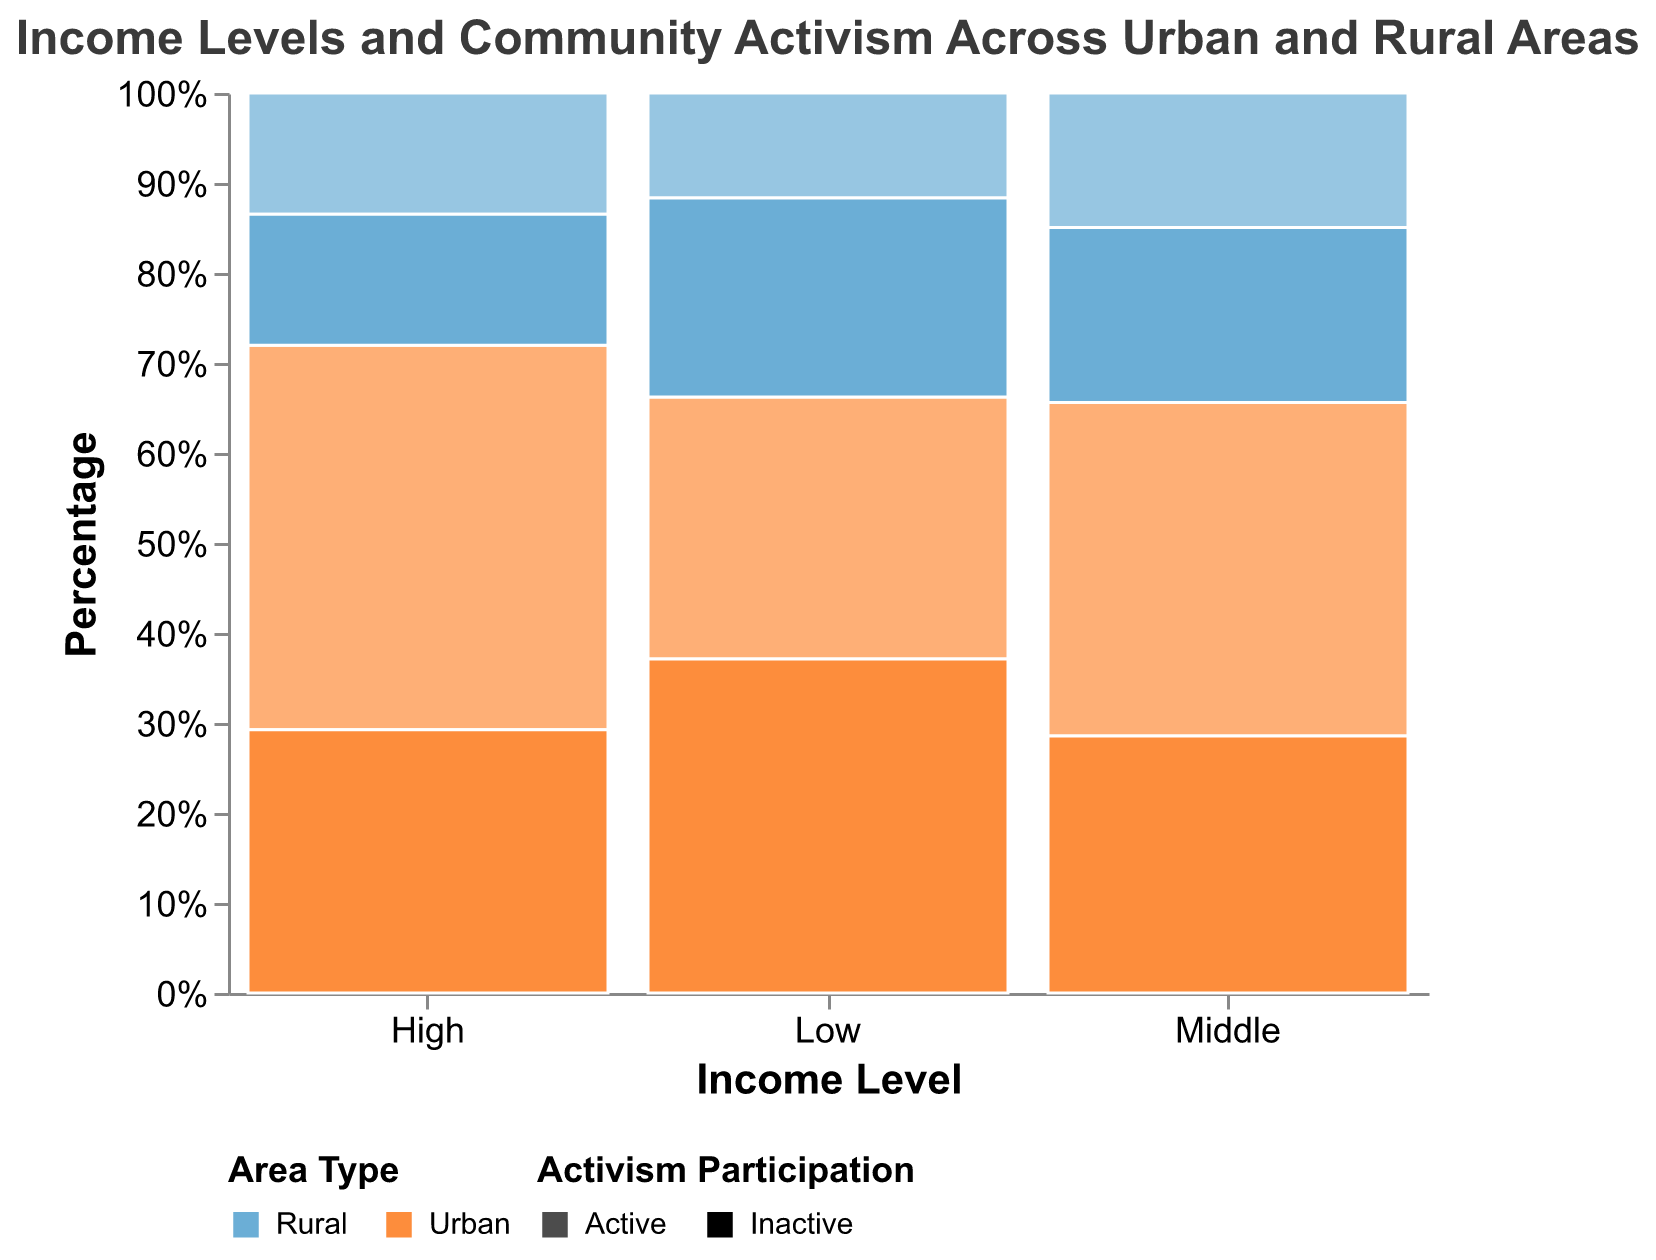How does the percentage of activism participation compare between middle-income rural and urban areas? To find this answer, you need to look at the height of the bars representing middle-income level for both rural and urban areas. The bar height shows the percentage of activism participation for each area type. Middle-income urban participants have a higher percentage of activism compared to their rural counterparts.
Answer: Middle-income urban has a higher percentage Which area type has a higher percentage of activism participation among high-income individuals? Check the bars for high-income levels and compare the percentage of activism for urban and rural. The percentage is represented by the relative height of the bar segments. The urban area has a higher percentage of activism participation among high-income individuals compared to rural areas.
Answer: Urban In the urban areas, which income level shows the highest percentage of activism participation? Look at the urban bars and check which income level's "active" segment occupies a larger portion relative to others. The middle-income level in urban areas shows the highest percentage of activism participation.
Answer: Middle-income Between low and high-income groups in rural areas, which group is more likely to participate in community activism? Compare the height of the "active" segments for low-income and high-income groups within rural areas. The low-income group has a higher percentage of activism participation in rural areas compared to the high-income group.
Answer: Low-income What is the overall trend in activism participation as income levels increase in urban areas? Observe the bars for urban areas as income levels increase and note how the "active" segments change. In urban areas, the percentage of activism participation seems to peak at the middle-income level and then slightly decreases for high-income individuals.
Answer: Peaks at middle-income, then decreases What is the specific percentage of middle-income urban individuals who are inactive? Look at the middle-income urban bar segment marked as "inactive" and refer to its height. The percentage of middle-income urban individuals who are inactive can be observed at approximately 43.5% from the stacked bar representing "inactive" in that segment.
Answer: Approximately 43.5% In rural areas, which income level has the lowest percentage of activists? Compare the "active" segments of the bars for all income levels in rural areas to find the smallest one. The high-income level in rural areas has the lowest percentage of activists.
Answer: High-income What insights can be derived regarding community activism between urban and rural areas across all income levels? Compare the urban and rural bars side-by-side across all income levels, focusing on the "active" and "inactive" segments. Urban areas generally have higher percentages of community activism participation across all income levels compared to rural areas.
Answer: Urban areas have higher percentages What is the combined percentage of active participants for low-income individuals in both urban and rural areas? Calculate the percentage contribution of the "active" segments for low-income individuals in both urban and rural areas and sum them up.  The combined percentage is around 32.8% ((245 / 841) for urban + (98 / 284) for rural).
Answer: Approximately 32.8% How does the distribution of inactive participants differ between middle-income urban and rural areas? Compare the "inactive" segments of the middle-income bars for urban and rural areas to note the distribution difference. The urban middle-income group has a higher percentage of inactive participants compared to the rural middle-income group.
Answer: Higher in urban 